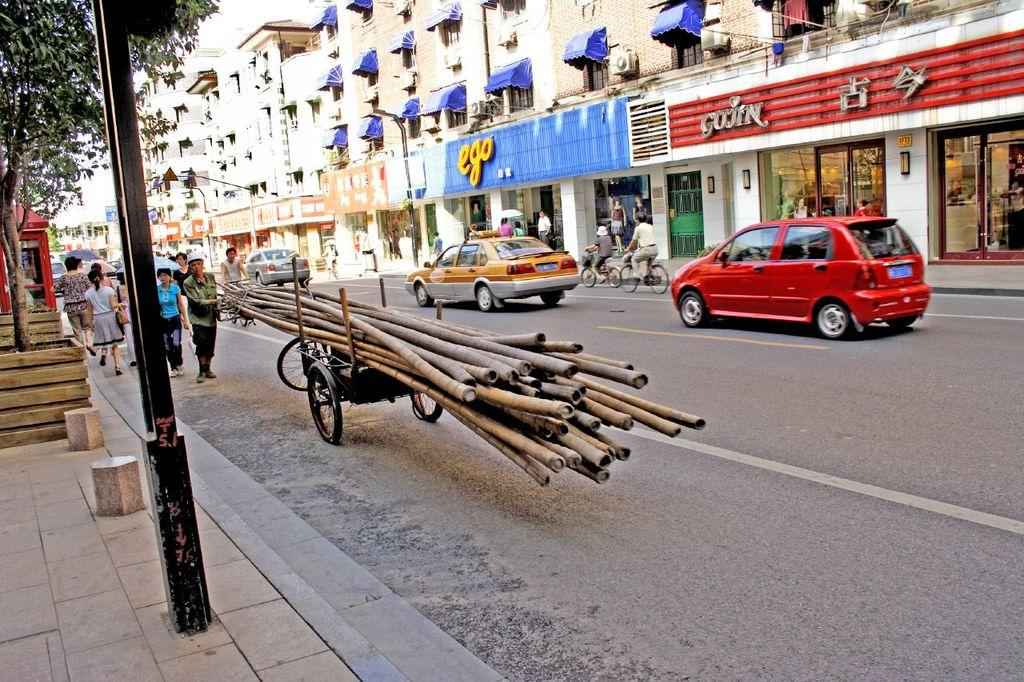<image>
Give a short and clear explanation of the subsequent image. A city street featuring stores like Ego and Gojin. 